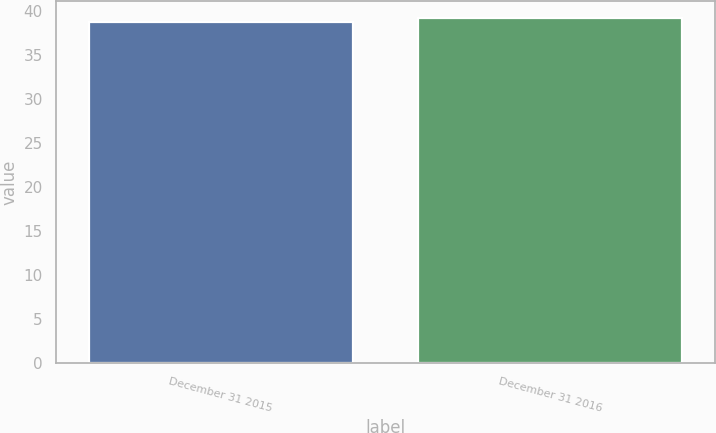Convert chart. <chart><loc_0><loc_0><loc_500><loc_500><bar_chart><fcel>December 31 2015<fcel>December 31 2016<nl><fcel>38.85<fcel>39.22<nl></chart> 